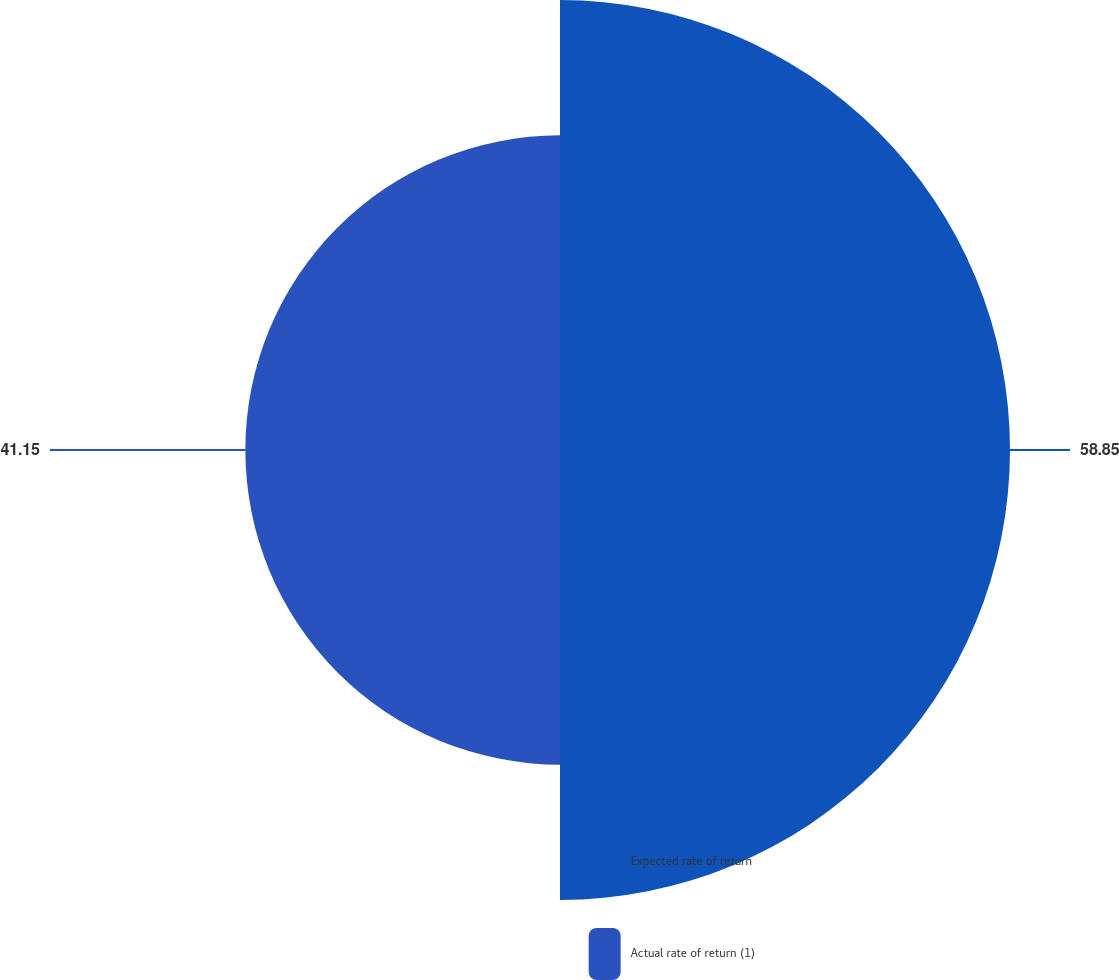Convert chart. <chart><loc_0><loc_0><loc_500><loc_500><pie_chart><fcel>Expected rate of return<fcel>Actual rate of return (1)<nl><fcel>58.85%<fcel>41.15%<nl></chart> 